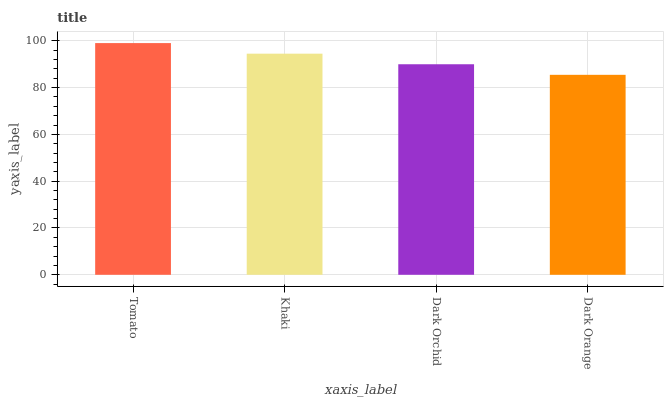Is Dark Orange the minimum?
Answer yes or no. Yes. Is Tomato the maximum?
Answer yes or no. Yes. Is Khaki the minimum?
Answer yes or no. No. Is Khaki the maximum?
Answer yes or no. No. Is Tomato greater than Khaki?
Answer yes or no. Yes. Is Khaki less than Tomato?
Answer yes or no. Yes. Is Khaki greater than Tomato?
Answer yes or no. No. Is Tomato less than Khaki?
Answer yes or no. No. Is Khaki the high median?
Answer yes or no. Yes. Is Dark Orchid the low median?
Answer yes or no. Yes. Is Tomato the high median?
Answer yes or no. No. Is Dark Orange the low median?
Answer yes or no. No. 